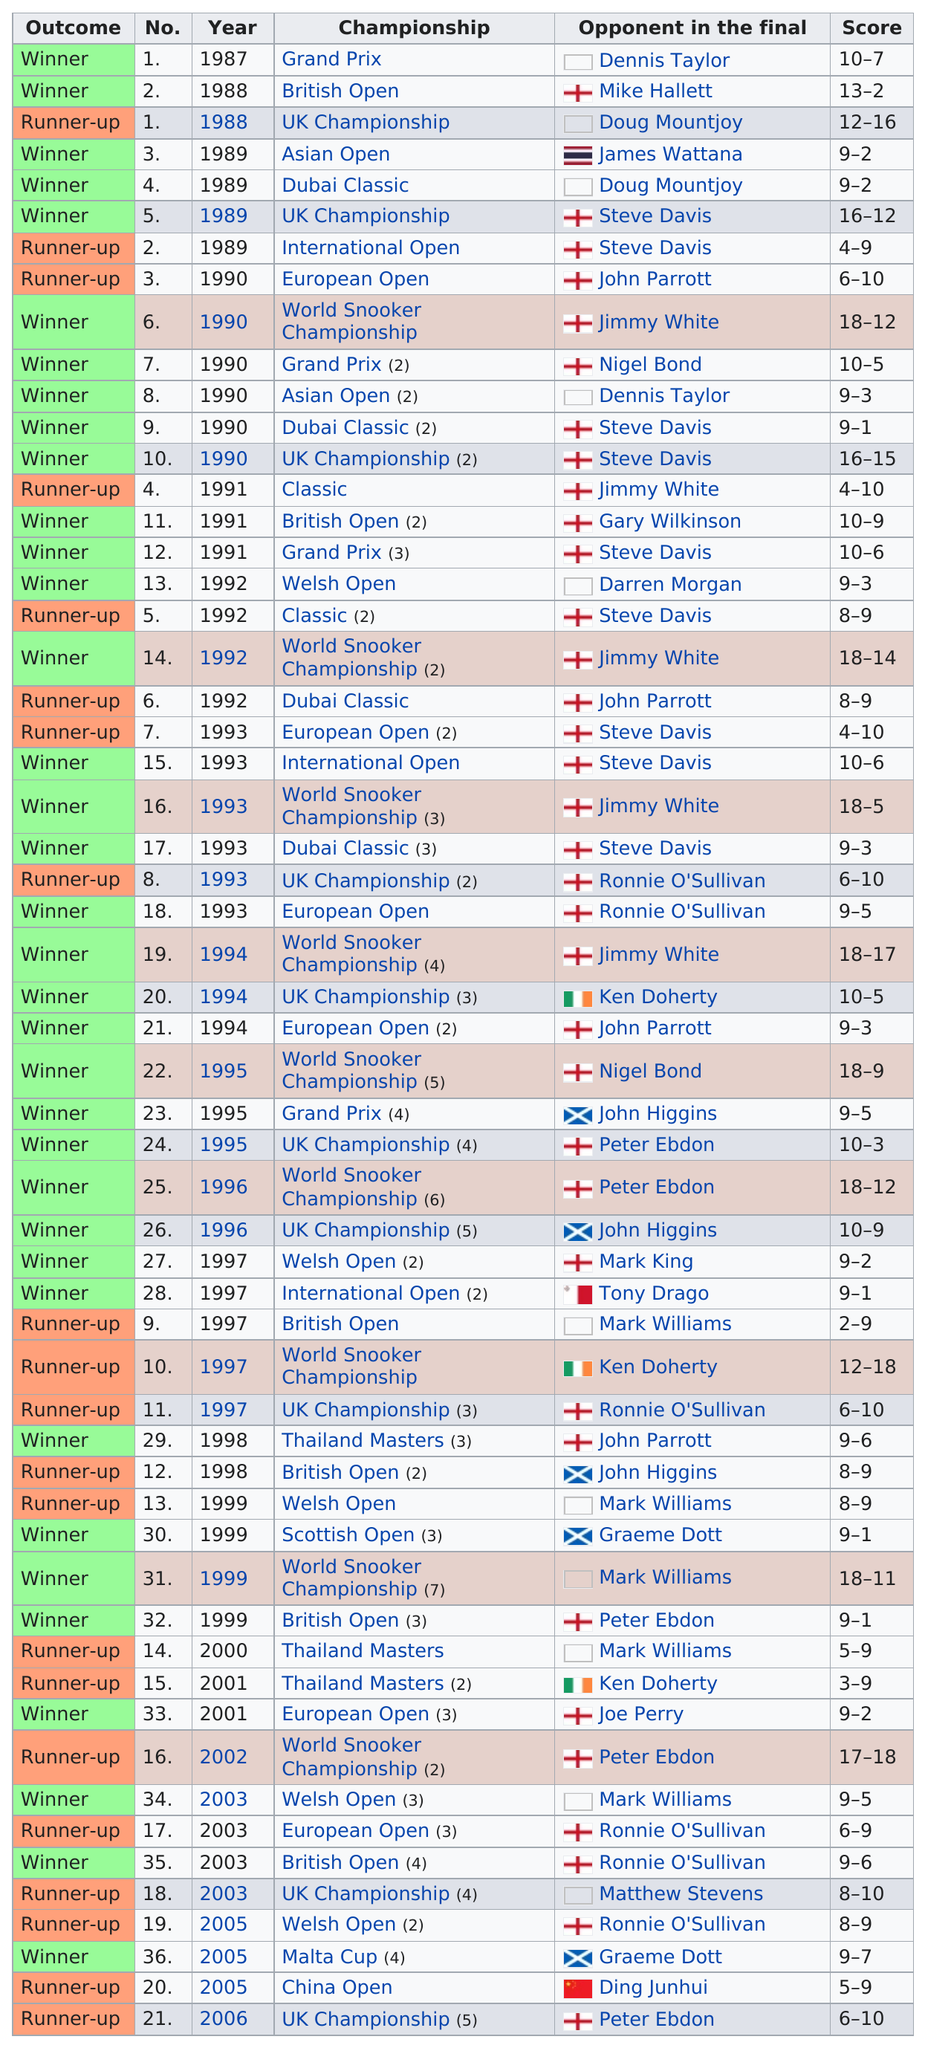Identify some key points in this picture. He won at least 3 times for 6 years. In the year 1990, he won the most titles. His professional career lasted 19 years. Stephen Hendry won his first title in 1987. In the end, the winner emerged victorious, while the runner-up was left to ponder his second place finish. 